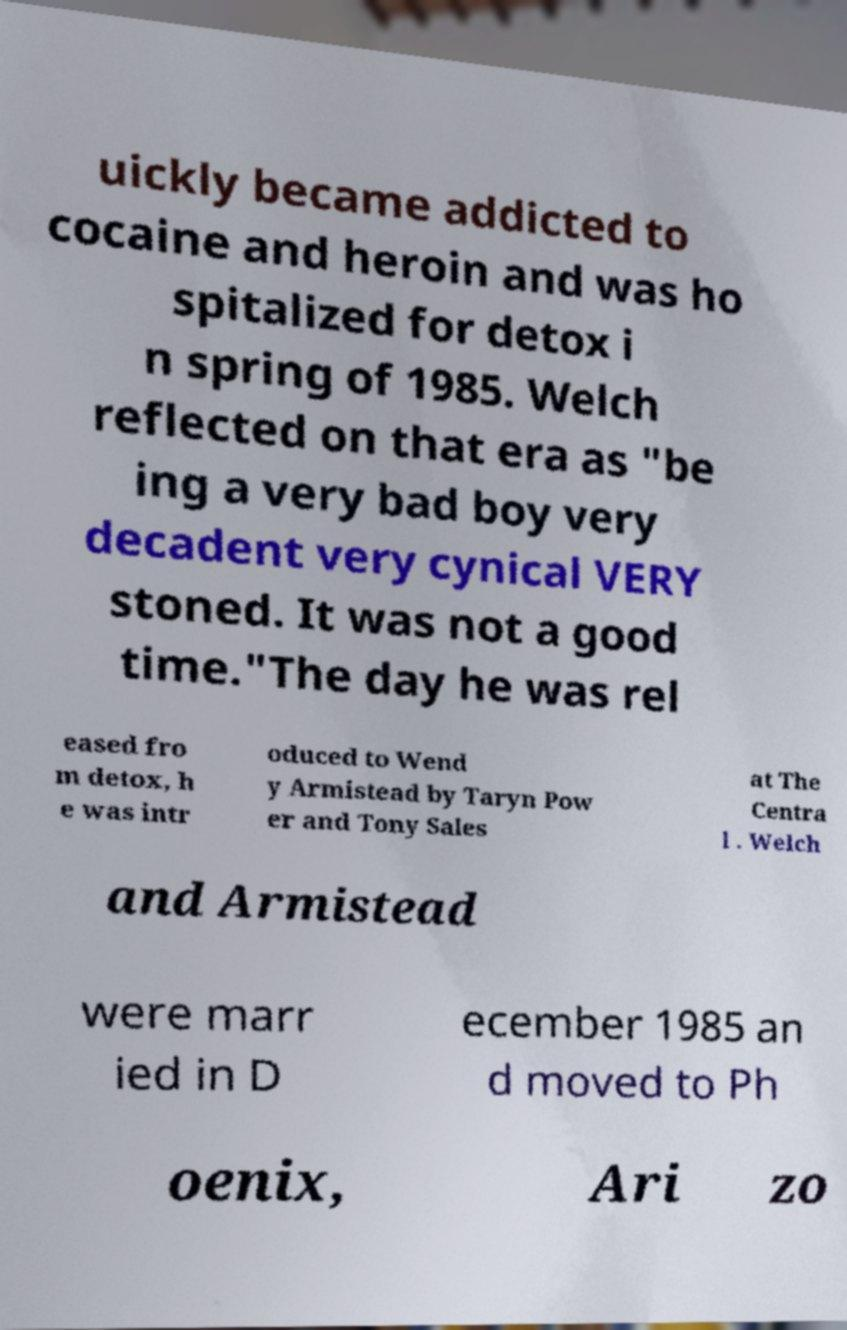I need the written content from this picture converted into text. Can you do that? uickly became addicted to cocaine and heroin and was ho spitalized for detox i n spring of 1985. Welch reflected on that era as "be ing a very bad boy very decadent very cynical VERY stoned. It was not a good time."The day he was rel eased fro m detox, h e was intr oduced to Wend y Armistead by Taryn Pow er and Tony Sales at The Centra l . Welch and Armistead were marr ied in D ecember 1985 an d moved to Ph oenix, Ari zo 